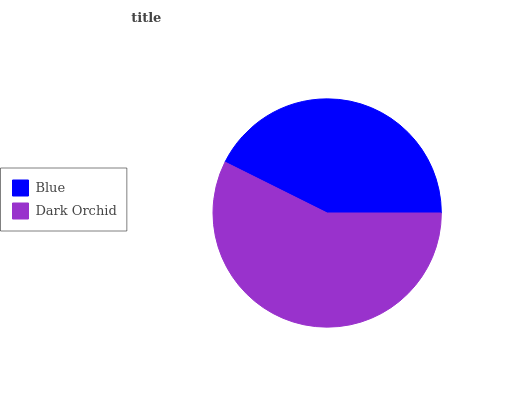Is Blue the minimum?
Answer yes or no. Yes. Is Dark Orchid the maximum?
Answer yes or no. Yes. Is Dark Orchid the minimum?
Answer yes or no. No. Is Dark Orchid greater than Blue?
Answer yes or no. Yes. Is Blue less than Dark Orchid?
Answer yes or no. Yes. Is Blue greater than Dark Orchid?
Answer yes or no. No. Is Dark Orchid less than Blue?
Answer yes or no. No. Is Dark Orchid the high median?
Answer yes or no. Yes. Is Blue the low median?
Answer yes or no. Yes. Is Blue the high median?
Answer yes or no. No. Is Dark Orchid the low median?
Answer yes or no. No. 